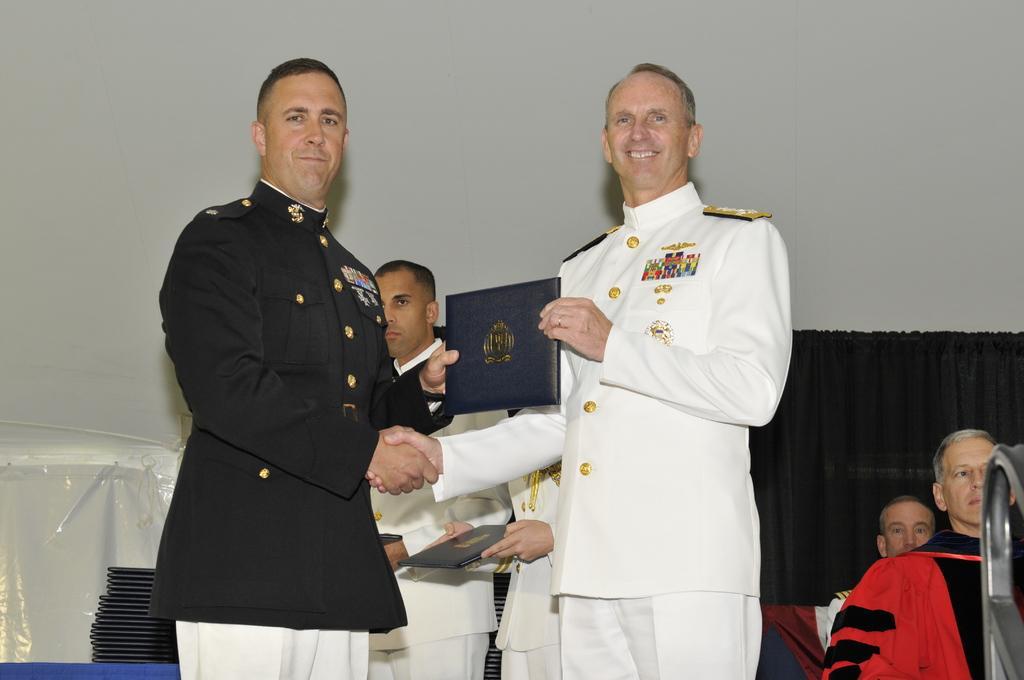Could you give a brief overview of what you see in this image? In front of the image there are two people shaking their hands and they are holding the book. Behind them there are two other people standing. Beside them there is a table. On top of it there are books. On the right side of the image there is a metal rod. There are people sitting on the chairs. In the background of the image there is a black curtain. There is a wall. 